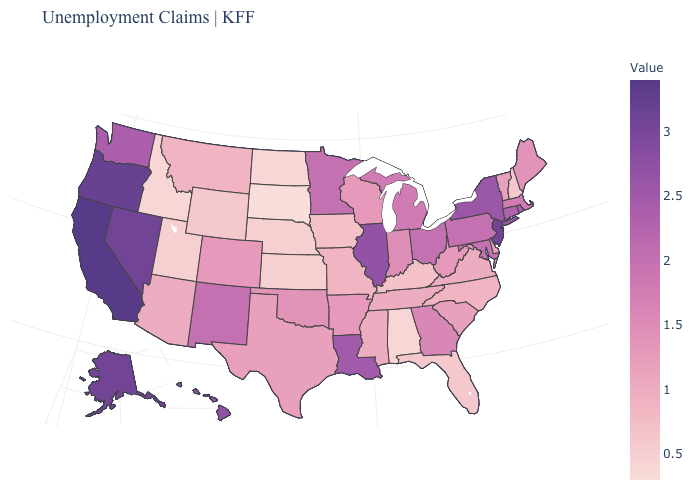Does California have the highest value in the USA?
Be succinct. Yes. Among the states that border New Jersey , does Delaware have the lowest value?
Give a very brief answer. Yes. Which states hav the highest value in the Northeast?
Answer briefly. New Jersey. Does Texas have the highest value in the South?
Quick response, please. No. Is the legend a continuous bar?
Quick response, please. Yes. Which states have the highest value in the USA?
Be succinct. California. Which states hav the highest value in the South?
Quick response, please. Louisiana. Among the states that border Nebraska , does Colorado have the highest value?
Short answer required. Yes. 